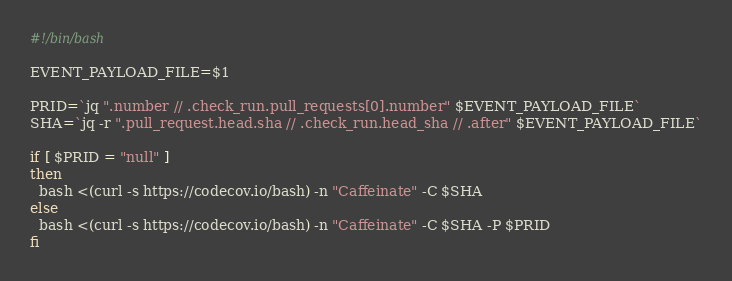<code> <loc_0><loc_0><loc_500><loc_500><_Bash_>#!/bin/bash

EVENT_PAYLOAD_FILE=$1

PRID=`jq ".number // .check_run.pull_requests[0].number" $EVENT_PAYLOAD_FILE`
SHA=`jq -r ".pull_request.head.sha // .check_run.head_sha // .after" $EVENT_PAYLOAD_FILE`

if [ $PRID = "null" ]
then
  bash <(curl -s https://codecov.io/bash) -n "Caffeinate" -C $SHA
else
  bash <(curl -s https://codecov.io/bash) -n "Caffeinate" -C $SHA -P $PRID
fi
</code> 